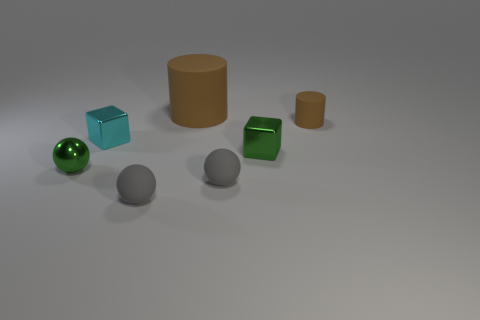Add 1 small metallic spheres. How many objects exist? 8 Subtract all spheres. How many objects are left? 4 Add 2 blocks. How many blocks are left? 4 Add 7 small green metallic cubes. How many small green metallic cubes exist? 8 Subtract 0 blue cubes. How many objects are left? 7 Subtract all tiny cyan things. Subtract all large matte cylinders. How many objects are left? 5 